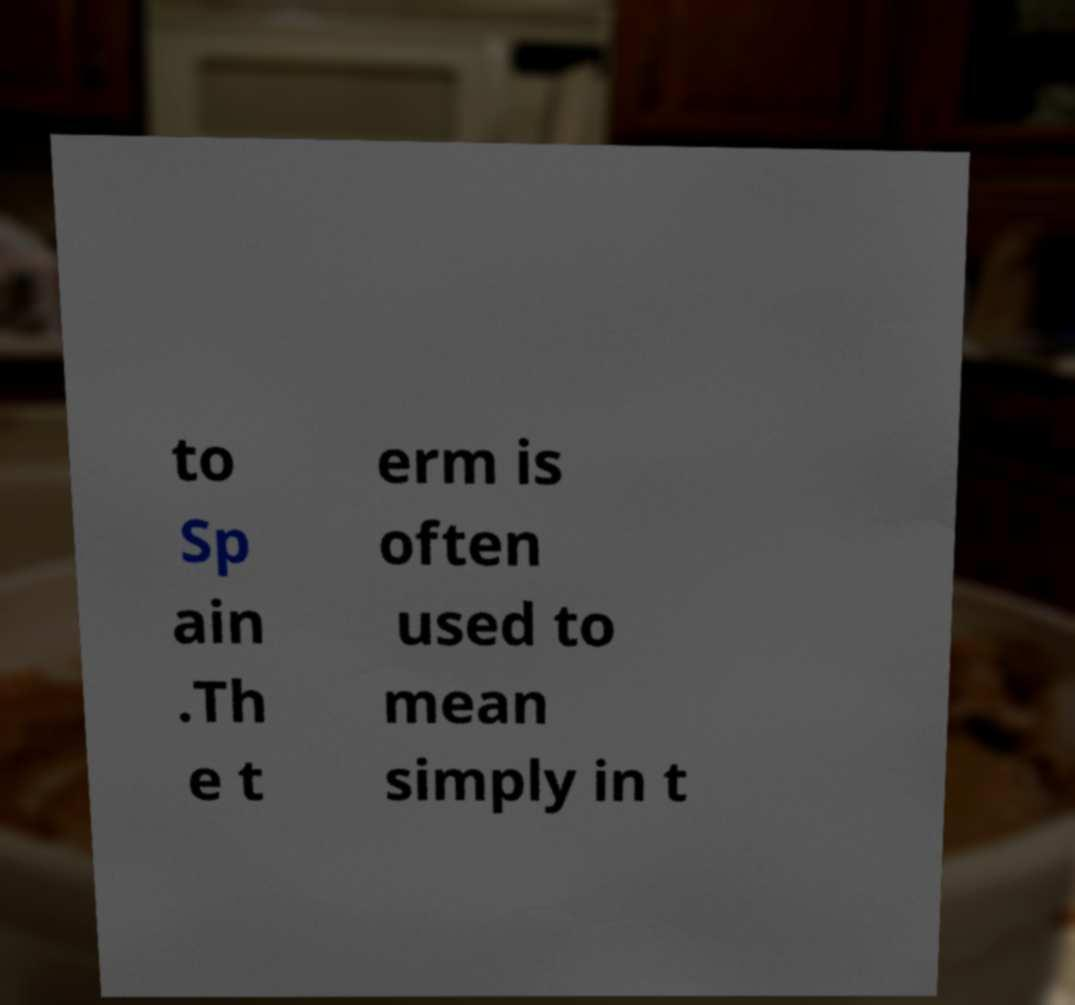Please read and relay the text visible in this image. What does it say? to Sp ain .Th e t erm is often used to mean simply in t 